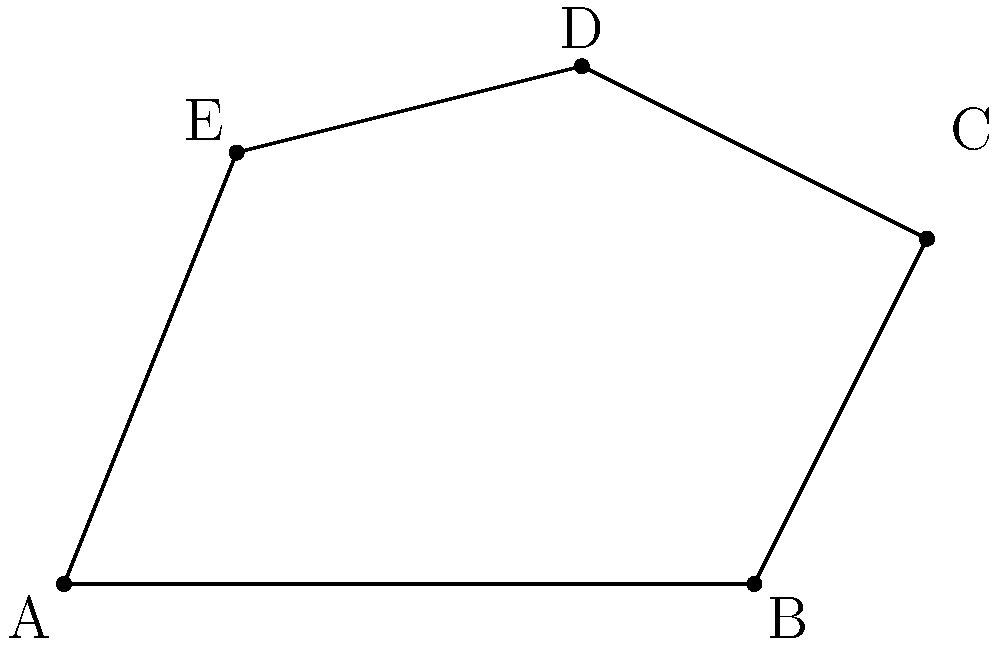At a music festival, a unique concert arena has been designed in the shape of an irregular pentagon to accommodate various stage setups and create an immersive experience for the audience. The arena's vertices are given by the coordinates A(0,0), B(8,0), C(10,4), D(6,6), and E(2,5) in a Cartesian plane where each unit represents 10 meters. Calculate the total area of this concert arena in square meters. To find the area of this irregular pentagon, we can use the shoelace formula (also known as the surveyor's formula). The steps are as follows:

1) The shoelace formula for a polygon with vertices $(x_1, y_1), (x_2, y_2), ..., (x_n, y_n)$ is:

   Area = $\frac{1}{2}|x_1y_2 + x_2y_3 + ... + x_ny_1 - y_1x_2 - y_2x_3 - ... - y_nx_1|$

2) Substituting our coordinates:
   A(0,0), B(8,0), C(10,4), D(6,6), E(2,5)

3) Applying the formula:

   Area = $\frac{1}{2}|(0 \cdot 0 + 8 \cdot 4 + 10 \cdot 6 + 6 \cdot 5 + 2 \cdot 0) - (0 \cdot 8 + 0 \cdot 10 + 4 \cdot 6 + 6 \cdot 2 + 5 \cdot 0)|$

4) Simplifying:
   Area = $\frac{1}{2}|(0 + 32 + 60 + 30 + 0) - (0 + 0 + 24 + 12 + 0)|$
   Area = $\frac{1}{2}|122 - 36|$
   Area = $\frac{1}{2} \cdot 86 = 43$

5) Since each unit represents 10 meters, we need to multiply our result by 100 to get the area in square meters:

   43 * 100 = 4300 square meters

Therefore, the total area of the concert arena is 4300 square meters.
Answer: 4300 square meters 